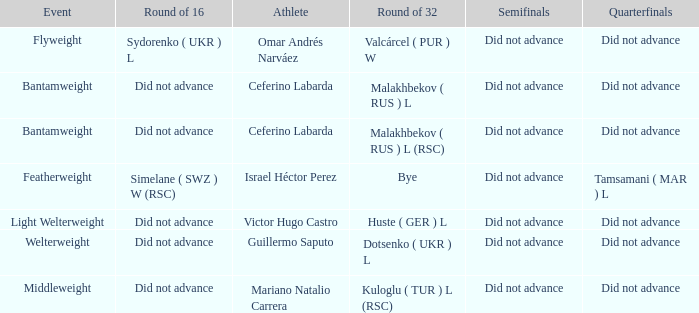When there was a bye in the round of 32, what was the result in the round of 16? Did not advance. 